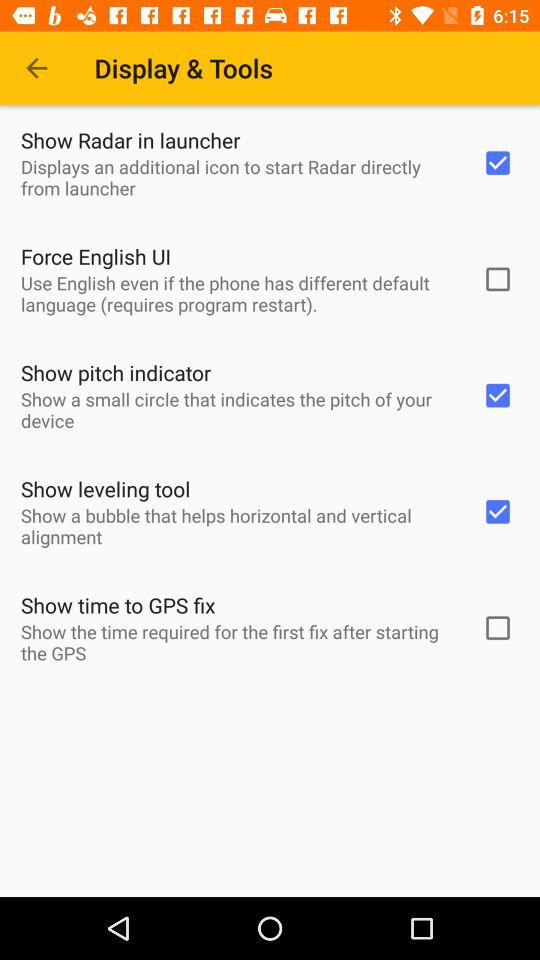Which are the selected options for Display & Tools? The selected options for Display & Tools are : "Show Radar in launcher", "Show pitch indicator", and "Show leveling tool". 